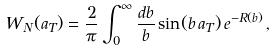Convert formula to latex. <formula><loc_0><loc_0><loc_500><loc_500>W _ { N } ( a _ { T } ) = \frac { 2 } { \pi } \int _ { 0 } ^ { \infty } \frac { d b } { b } \sin ( b \, a _ { T } ) \, e ^ { - R ( b ) } \, ,</formula> 